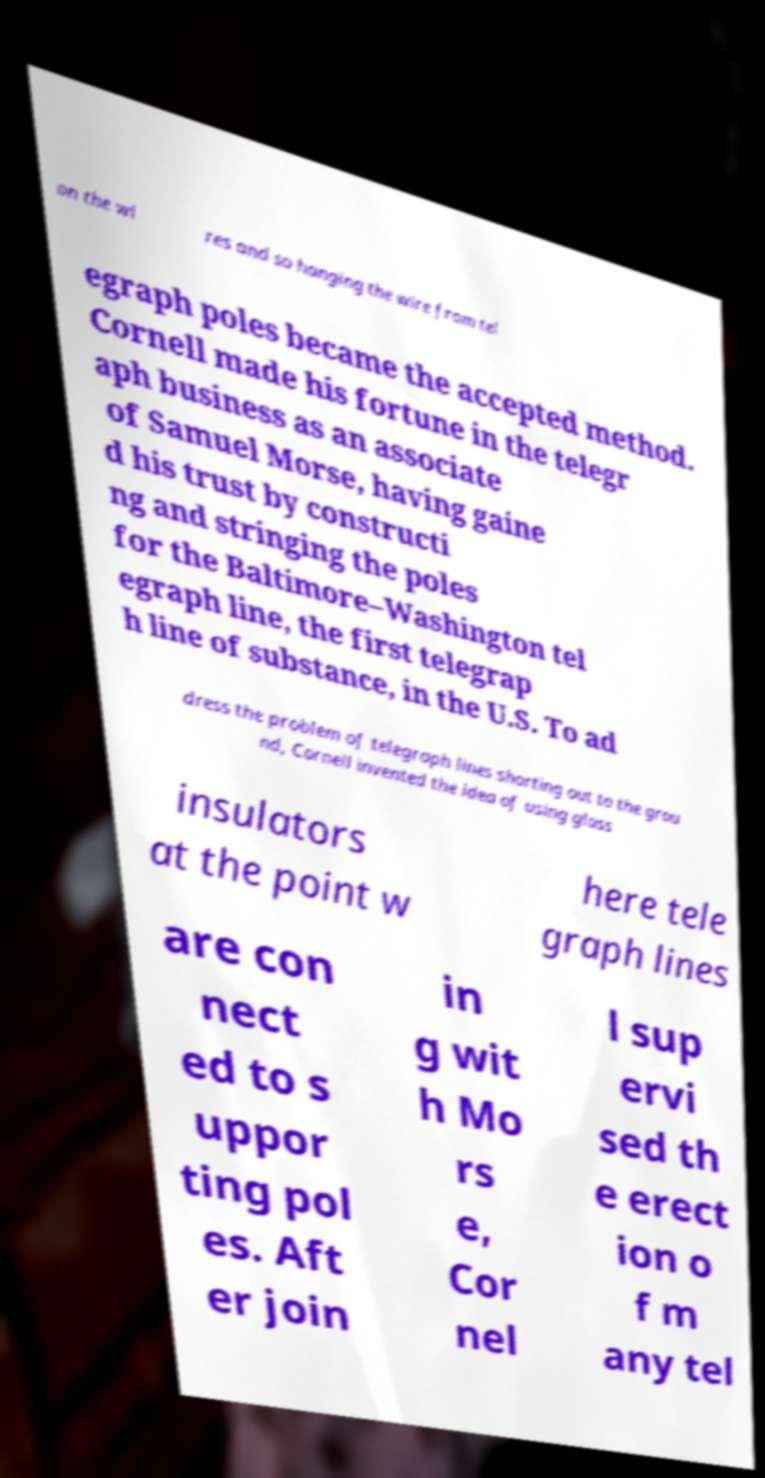There's text embedded in this image that I need extracted. Can you transcribe it verbatim? on the wi res and so hanging the wire from tel egraph poles became the accepted method. Cornell made his fortune in the telegr aph business as an associate of Samuel Morse, having gaine d his trust by constructi ng and stringing the poles for the Baltimore–Washington tel egraph line, the first telegrap h line of substance, in the U.S. To ad dress the problem of telegraph lines shorting out to the grou nd, Cornell invented the idea of using glass insulators at the point w here tele graph lines are con nect ed to s uppor ting pol es. Aft er join in g wit h Mo rs e, Cor nel l sup ervi sed th e erect ion o f m any tel 